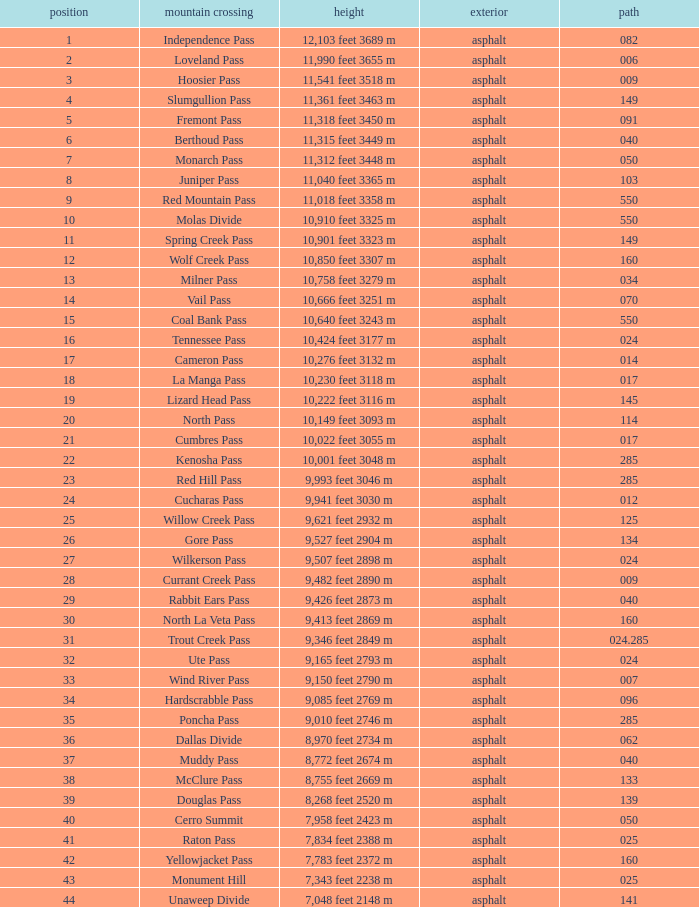What is the Surface of the Route less than 7? Asphalt. 